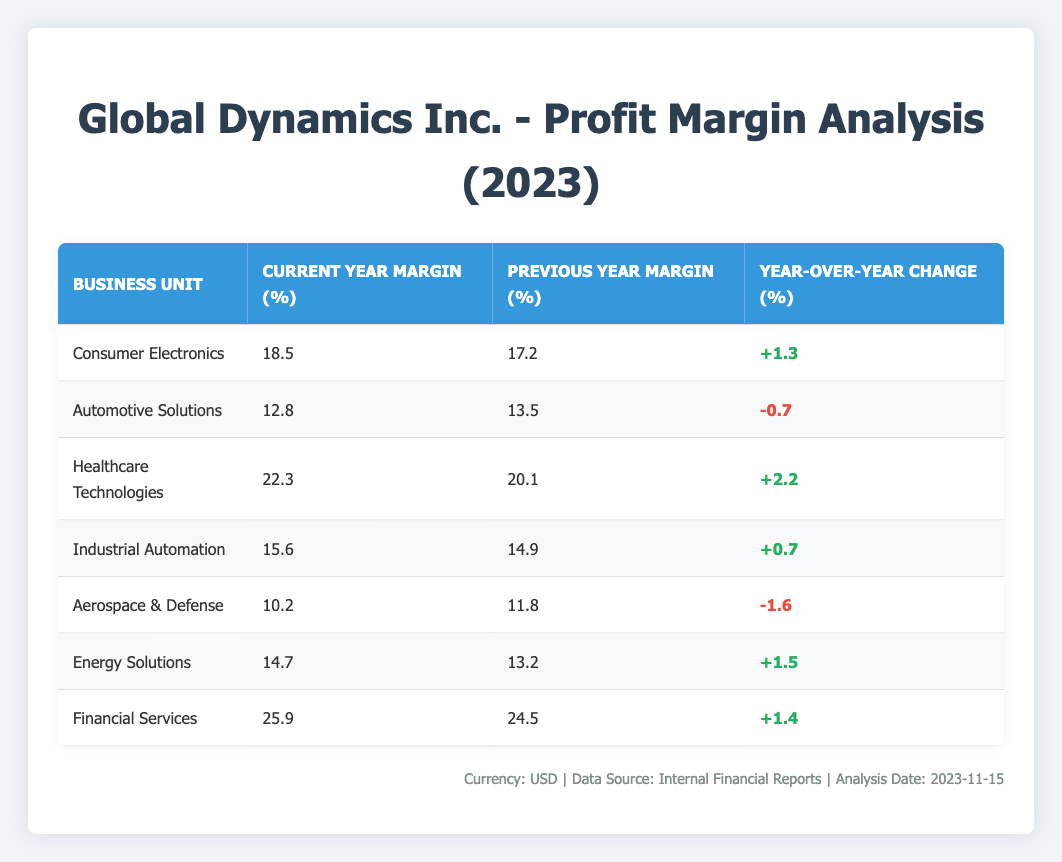What is the current year profit margin for Healthcare Technologies? The table lists the business units along with their current year margins. For Healthcare Technologies, the current year margin is specified as 22.3%.
Answer: 22.3% Which business unit had the highest year-over-year profit margin change? To find the highest year-over-year change, we compare the year-over-year changes for all business units. The changes are +1.3%, -0.7%, +2.2%, +0.7%, -1.6%, +1.5%, and +1.4%. The highest change is +2.2% for Healthcare Technologies.
Answer: Healthcare Technologies Is the profit margin for Aerospace & Defense higher than for Automotive Solutions in 2023? The table shows Aerospace & Defense at 10.2% and Automotive Solutions at 12.8%. Since 10.2% is less than 12.8%, Aerospace & Defense does not have a higher margin than Automotive Solutions.
Answer: No What is the average current year profit margin for the business units that showed a positive change? First, identify the business units with a positive change: Consumer Electronics (18.5%), Healthcare Technologies (22.3%), Industrial Automation (15.6%), Energy Solutions (14.7%), and Financial Services (25.9%). Adding these margins gives us: 18.5 + 22.3 + 15.6 + 14.7 + 25.9 = 97.0%. There are 5 units, so the average is 97.0 / 5 = 19.4%.
Answer: 19.4% Did Energy Solutions improve its profit margin from the previous year? The profit margin for Energy Solutions increased from 13.2% to 14.7%, indicating an improvement. Therefore, we conclude that Energy Solutions did indeed improve its profit margin.
Answer: Yes What is the total profit margin change for all business units combined? We sum the year-over-year changes across all business units: +1.3% + (-0.7%) + +2.2% + +0.7% + (-1.6%) + +1.5% + +1.4% = 5.8%. This provides the total change for all units.
Answer: 5.8% Which business unit had the lowest current year margin? Review the current year margins: 18.5%, 12.8%, 22.3%, 15.6%, 10.2%, 14.7%, and 25.9%. The lowest margin is 10.2% for Aerospace & Defense.
Answer: Aerospace & Defense What is the difference in profit margins between the Financial Services and the Industrial Automation units? For Financial Services, the margin is 25.9%, and for Industrial Automation, it is 15.6%. The difference is 25.9% - 15.6% = 10.3%. Thus, Financial Services has a significantly higher profit margin than Industrial Automation.
Answer: 10.3% 